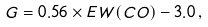Convert formula to latex. <formula><loc_0><loc_0><loc_500><loc_500>G = 0 . 5 6 \times E W ( C O ) - 3 . 0 \, ,</formula> 